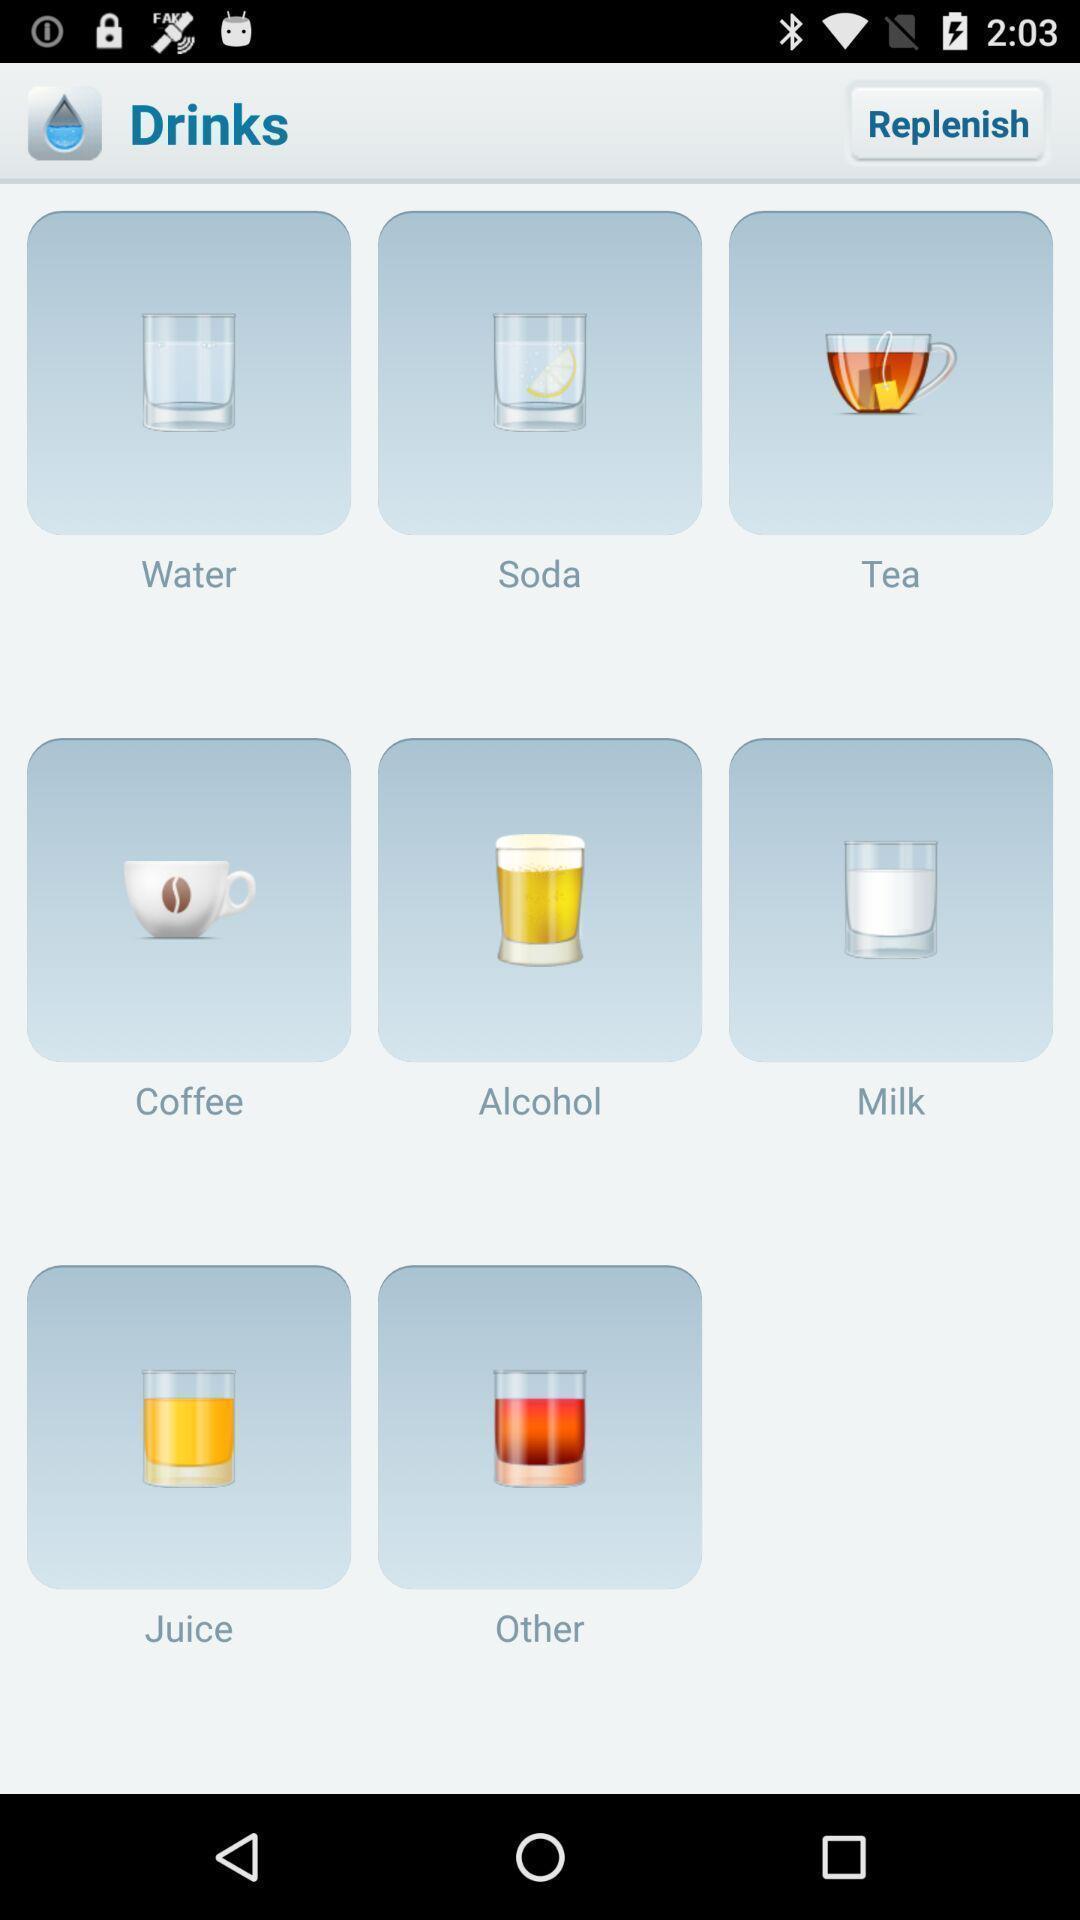Tell me what you see in this picture. Page showing the various option in drinks. 